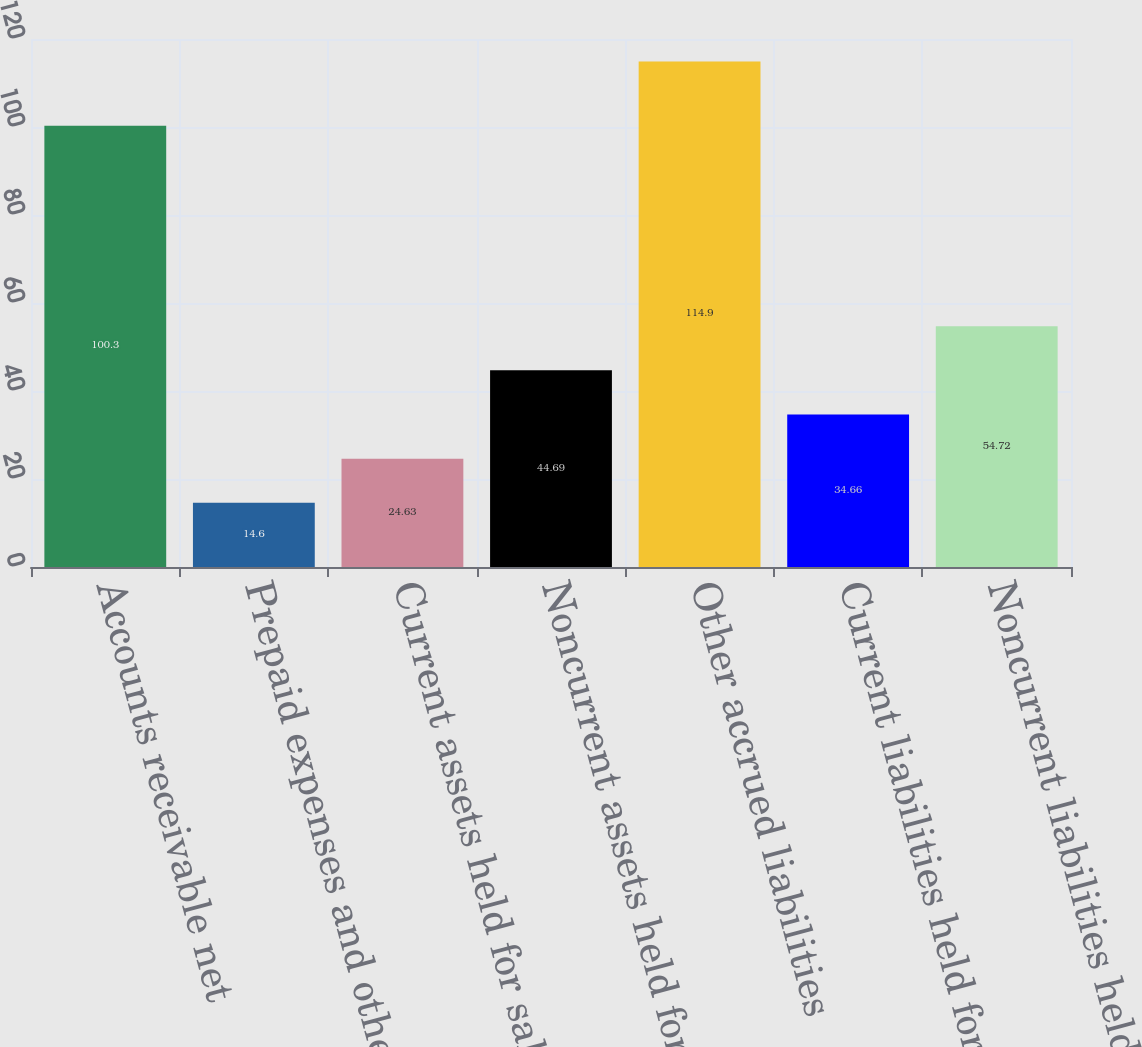<chart> <loc_0><loc_0><loc_500><loc_500><bar_chart><fcel>Accounts receivable net<fcel>Prepaid expenses and other<fcel>Current assets held for sale<fcel>Noncurrent assets held for<fcel>Other accrued liabilities<fcel>Current liabilities held for<fcel>Noncurrent liabilities held<nl><fcel>100.3<fcel>14.6<fcel>24.63<fcel>44.69<fcel>114.9<fcel>34.66<fcel>54.72<nl></chart> 